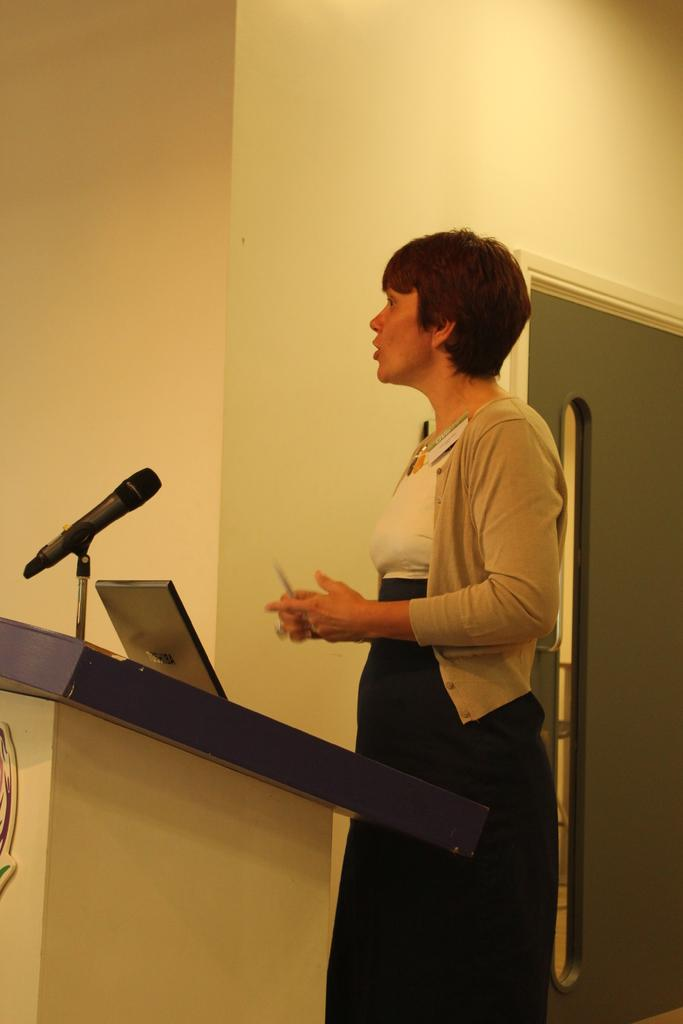Who is present in the image? There is a woman in the image. What is the woman doing in the image? The woman is standing at a desk. What object is on the desk in the image? The woman has a laptop on the desk. What can be seen in the background of the image? There is a wall and a door in the background of the image. What type of fowl is sitting on the laptop in the image? There is no fowl present on the laptop or in the image. How much payment is being made in the image? There is no payment being made in the image; it only shows a woman standing at a desk with a laptop. 